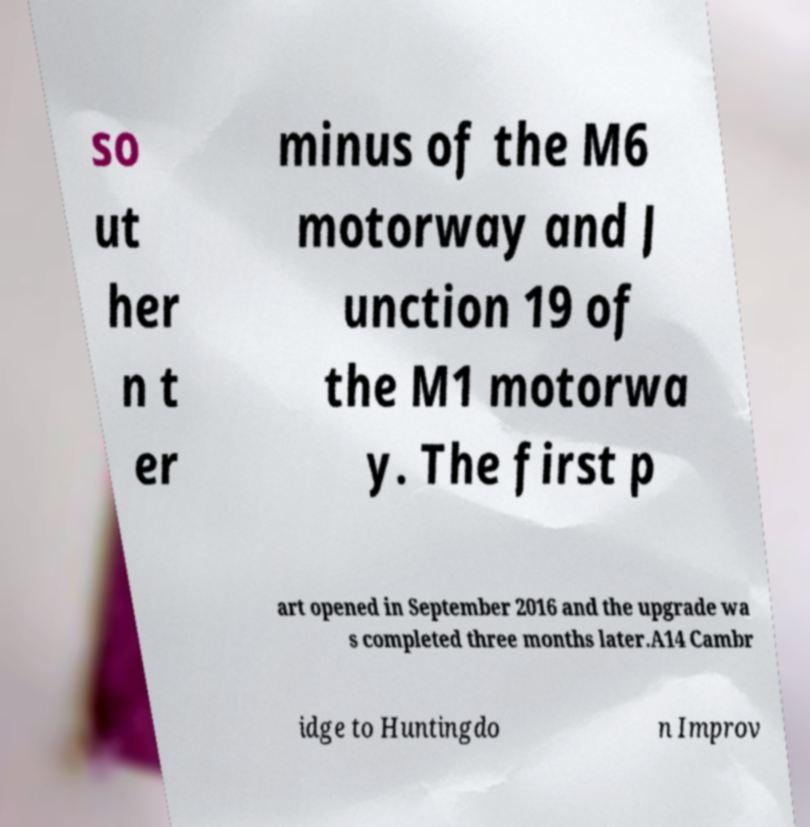Could you extract and type out the text from this image? so ut her n t er minus of the M6 motorway and J unction 19 of the M1 motorwa y. The first p art opened in September 2016 and the upgrade wa s completed three months later.A14 Cambr idge to Huntingdo n Improv 